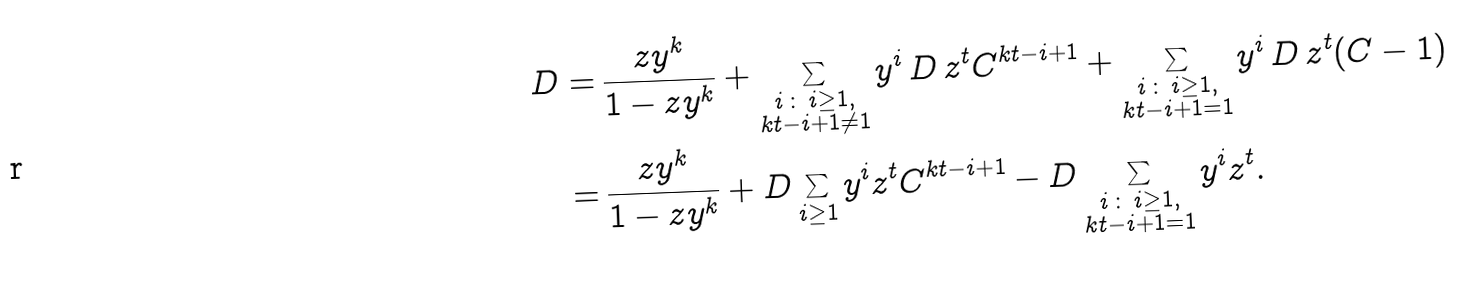Convert formula to latex. <formula><loc_0><loc_0><loc_500><loc_500>D = & \, \frac { z y ^ { k } } { 1 - z y ^ { k } } + \sum _ { \substack { i \, \colon \, i \geq 1 , \\ k t - i + 1 \ne 1 } } y ^ { i } \, D \, z ^ { t } C ^ { k t - i + 1 } + \sum _ { \substack { i \, \colon \, i \geq 1 , \\ k t - i + 1 = 1 } } y ^ { i } \, D \, z ^ { t } ( C - 1 ) \\ = & \, \frac { z y ^ { k } } { 1 - z y ^ { k } } + D \sum _ { i \geq 1 } y ^ { i } z ^ { t } C ^ { k t - i + 1 } - D \sum _ { \substack { i \, \colon \, i \geq 1 , \\ k t - i + 1 = 1 } } y ^ { i } z ^ { t } .</formula> 